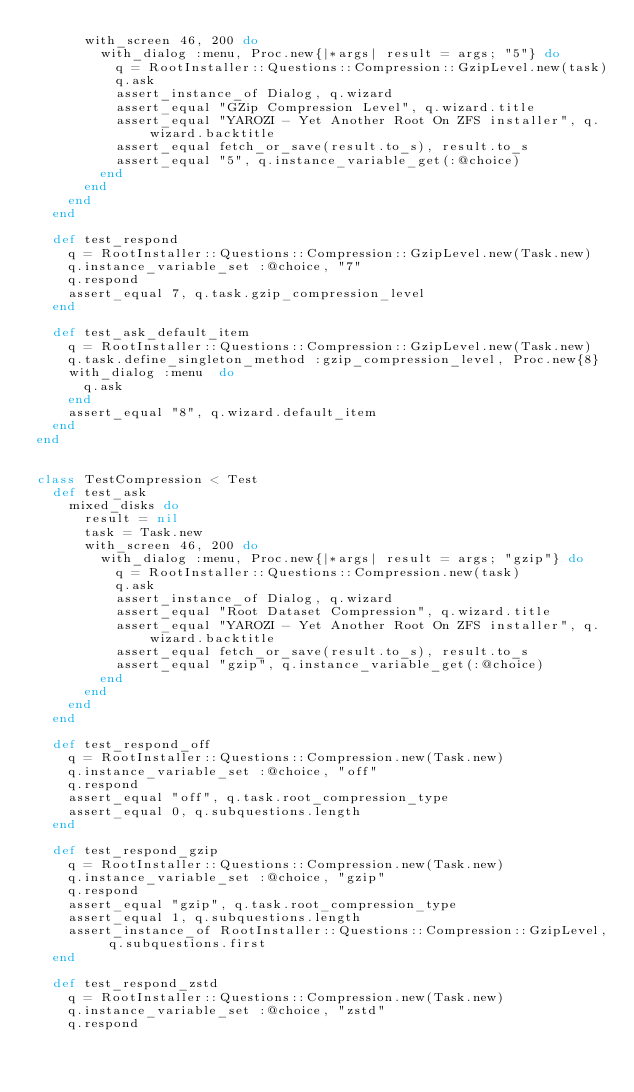<code> <loc_0><loc_0><loc_500><loc_500><_Ruby_>      with_screen 46, 200 do
        with_dialog :menu, Proc.new{|*args| result = args; "5"} do
          q = RootInstaller::Questions::Compression::GzipLevel.new(task)
          q.ask
          assert_instance_of Dialog, q.wizard
          assert_equal "GZip Compression Level", q.wizard.title
          assert_equal "YAROZI - Yet Another Root On ZFS installer", q.wizard.backtitle
          assert_equal fetch_or_save(result.to_s), result.to_s
          assert_equal "5", q.instance_variable_get(:@choice)
        end
      end  
    end  
  end

  def test_respond
    q = RootInstaller::Questions::Compression::GzipLevel.new(Task.new)
    q.instance_variable_set :@choice, "7"
    q.respond
    assert_equal 7, q.task.gzip_compression_level
  end

  def test_ask_default_item
    q = RootInstaller::Questions::Compression::GzipLevel.new(Task.new)
    q.task.define_singleton_method :gzip_compression_level, Proc.new{8}
    with_dialog :menu  do
      q.ask
    end
    assert_equal "8", q.wizard.default_item
  end
end


class TestCompression < Test
  def test_ask
    mixed_disks do
      result = nil
      task = Task.new
      with_screen 46, 200 do
        with_dialog :menu, Proc.new{|*args| result = args; "gzip"} do
          q = RootInstaller::Questions::Compression.new(task)
          q.ask
          assert_instance_of Dialog, q.wizard
          assert_equal "Root Dataset Compression", q.wizard.title
          assert_equal "YAROZI - Yet Another Root On ZFS installer", q.wizard.backtitle
          assert_equal fetch_or_save(result.to_s), result.to_s
          assert_equal "gzip", q.instance_variable_get(:@choice)
        end
      end  
    end  
  end

  def test_respond_off
    q = RootInstaller::Questions::Compression.new(Task.new)
    q.instance_variable_set :@choice, "off"
    q.respond
    assert_equal "off", q.task.root_compression_type
    assert_equal 0, q.subquestions.length
  end

  def test_respond_gzip
    q = RootInstaller::Questions::Compression.new(Task.new)
    q.instance_variable_set :@choice, "gzip"
    q.respond
    assert_equal "gzip", q.task.root_compression_type
    assert_equal 1, q.subquestions.length
    assert_instance_of RootInstaller::Questions::Compression::GzipLevel, q.subquestions.first
  end

  def test_respond_zstd
    q = RootInstaller::Questions::Compression.new(Task.new)
    q.instance_variable_set :@choice, "zstd"
    q.respond</code> 